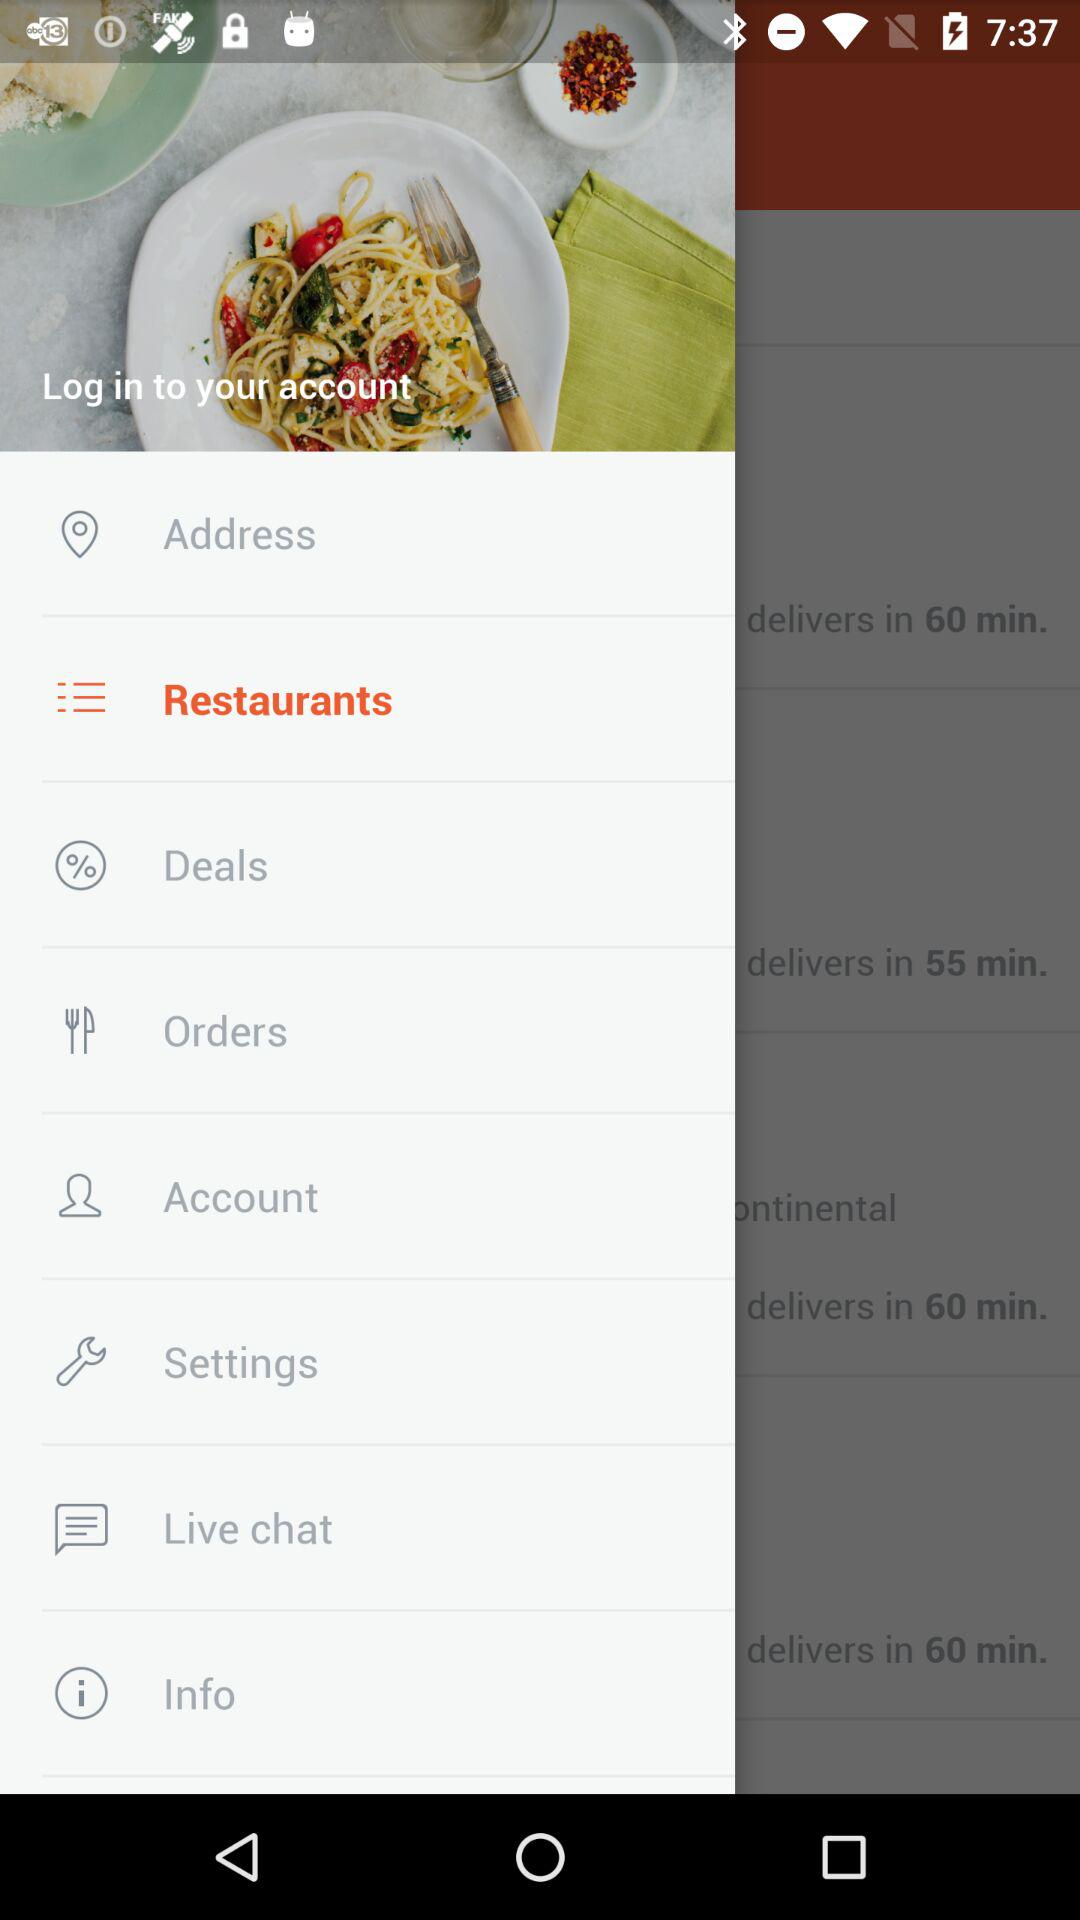How many notifications are there in "Orders"?
When the provided information is insufficient, respond with <no answer>. <no answer> 